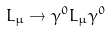Convert formula to latex. <formula><loc_0><loc_0><loc_500><loc_500>L _ { \mu } \rightarrow \gamma ^ { 0 } L _ { \mu } \gamma ^ { 0 }</formula> 